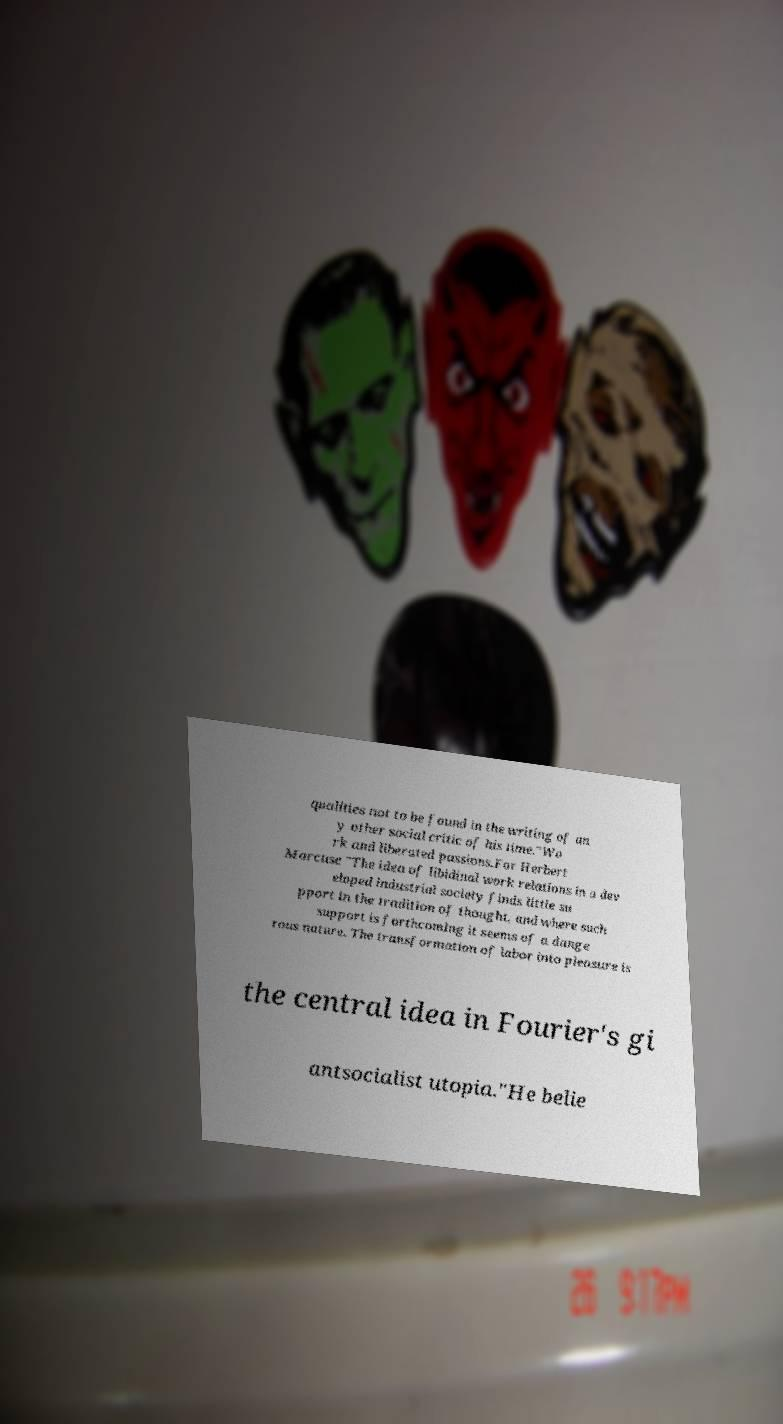Could you extract and type out the text from this image? qualities not to be found in the writing of an y other social critic of his time."Wo rk and liberated passions.For Herbert Marcuse "The idea of libidinal work relations in a dev eloped industrial society finds little su pport in the tradition of thought, and where such support is forthcoming it seems of a dange rous nature. The transformation of labor into pleasure is the central idea in Fourier's gi antsocialist utopia."He belie 